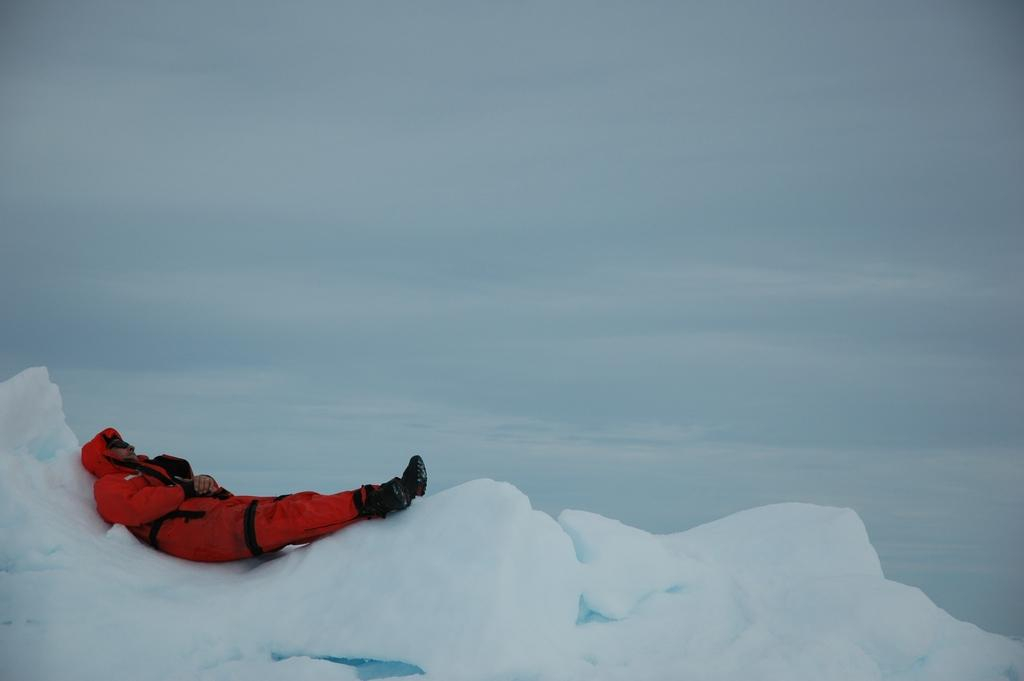What is the main subject of the image? There is a person in the image. What is the person wearing? The person is wearing a red dress. What is the person's position in the image? The person is lying on the ground. What is the unusual object on the ground in the image? There is an iceberg on the ground. What can be seen in the background of the image? The sky is visible in the background of the image. What type of veil is the person wearing in the image? There is no veil present in the image; the person is wearing a red dress. What color is the person's underwear in the image? There is no visible underwear in the image, as the person is wearing a red dress. 